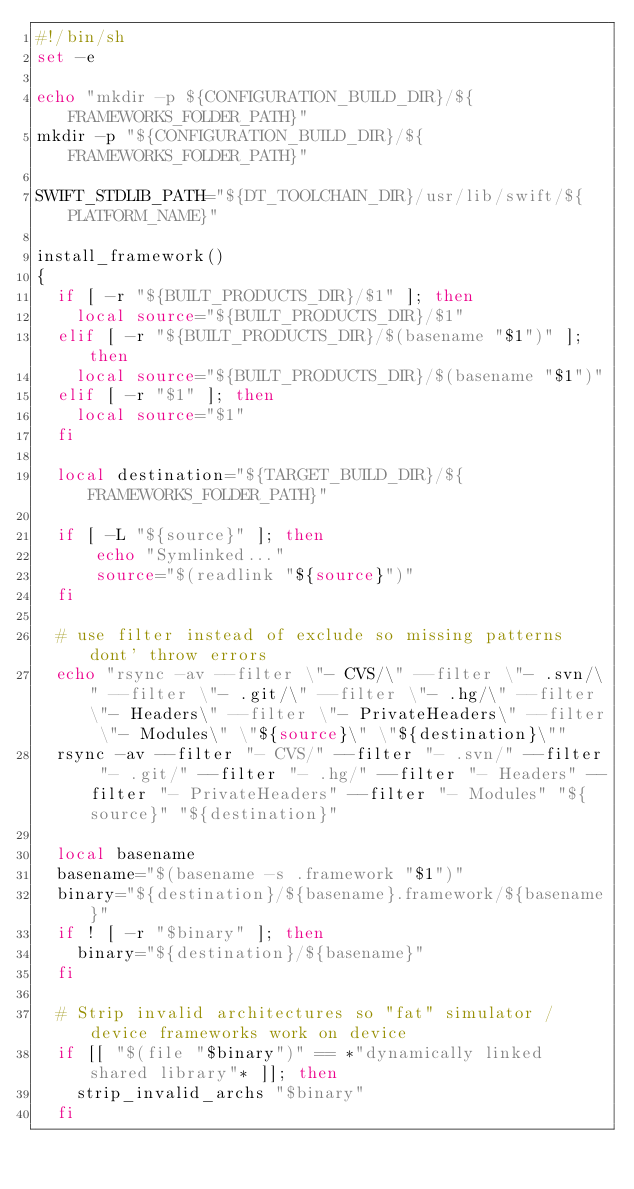<code> <loc_0><loc_0><loc_500><loc_500><_Bash_>#!/bin/sh
set -e

echo "mkdir -p ${CONFIGURATION_BUILD_DIR}/${FRAMEWORKS_FOLDER_PATH}"
mkdir -p "${CONFIGURATION_BUILD_DIR}/${FRAMEWORKS_FOLDER_PATH}"

SWIFT_STDLIB_PATH="${DT_TOOLCHAIN_DIR}/usr/lib/swift/${PLATFORM_NAME}"

install_framework()
{
  if [ -r "${BUILT_PRODUCTS_DIR}/$1" ]; then
    local source="${BUILT_PRODUCTS_DIR}/$1"
  elif [ -r "${BUILT_PRODUCTS_DIR}/$(basename "$1")" ]; then
    local source="${BUILT_PRODUCTS_DIR}/$(basename "$1")"
  elif [ -r "$1" ]; then
    local source="$1"
  fi

  local destination="${TARGET_BUILD_DIR}/${FRAMEWORKS_FOLDER_PATH}"

  if [ -L "${source}" ]; then
      echo "Symlinked..."
      source="$(readlink "${source}")"
  fi

  # use filter instead of exclude so missing patterns dont' throw errors
  echo "rsync -av --filter \"- CVS/\" --filter \"- .svn/\" --filter \"- .git/\" --filter \"- .hg/\" --filter \"- Headers\" --filter \"- PrivateHeaders\" --filter \"- Modules\" \"${source}\" \"${destination}\""
  rsync -av --filter "- CVS/" --filter "- .svn/" --filter "- .git/" --filter "- .hg/" --filter "- Headers" --filter "- PrivateHeaders" --filter "- Modules" "${source}" "${destination}"

  local basename
  basename="$(basename -s .framework "$1")"
  binary="${destination}/${basename}.framework/${basename}"
  if ! [ -r "$binary" ]; then
    binary="${destination}/${basename}"
  fi

  # Strip invalid architectures so "fat" simulator / device frameworks work on device
  if [[ "$(file "$binary")" == *"dynamically linked shared library"* ]]; then
    strip_invalid_archs "$binary"
  fi
</code> 